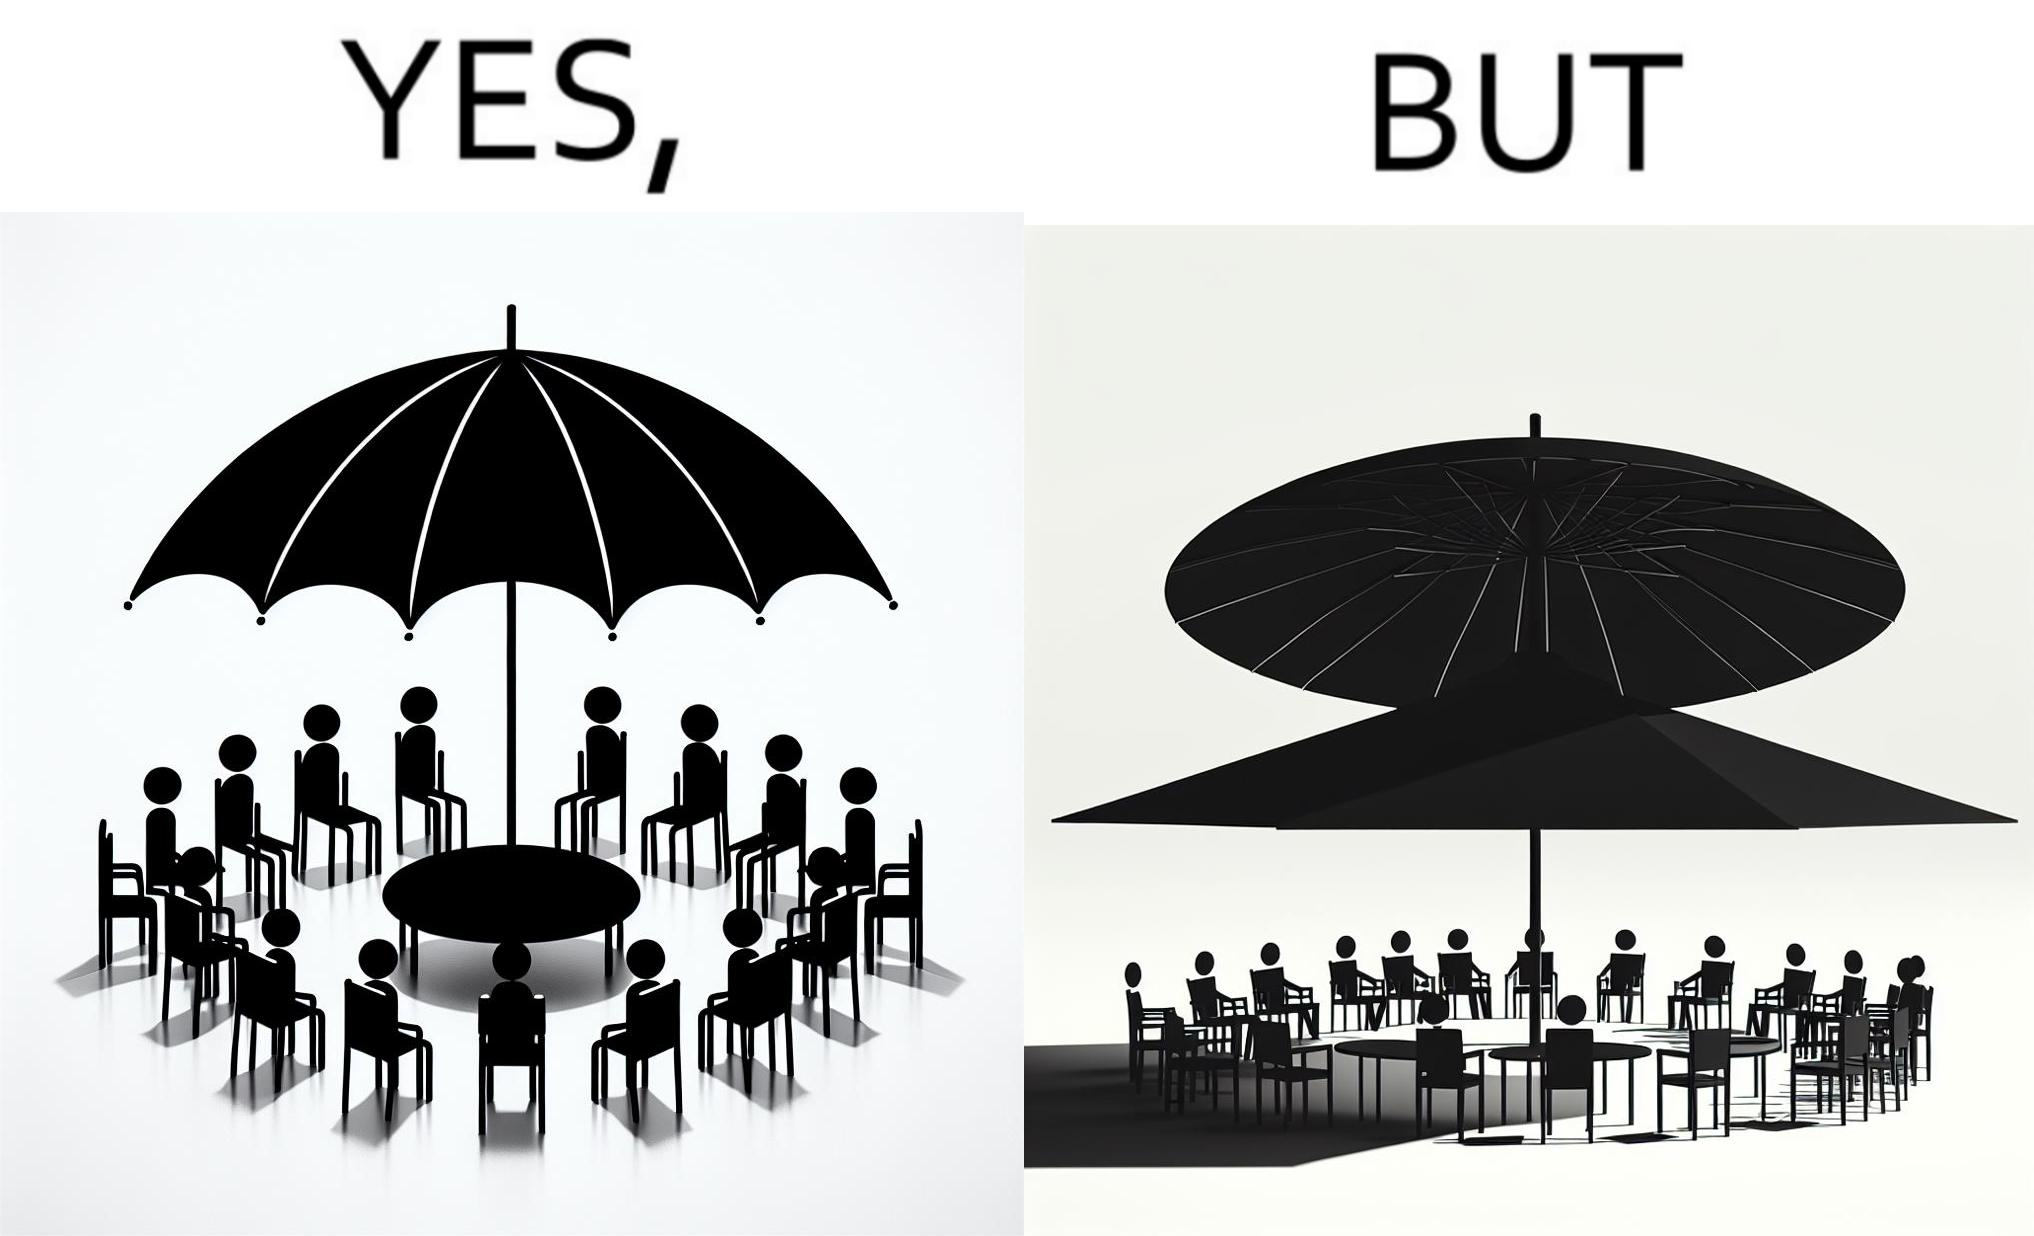Describe the content of this image. The image is ironical, as the umbrella is meant to provide shadow in the area where the chairs are present, but due to the orientation of the rays of the sun, all the chairs are in sunlight, and the umbrella is of no use in this situation. 